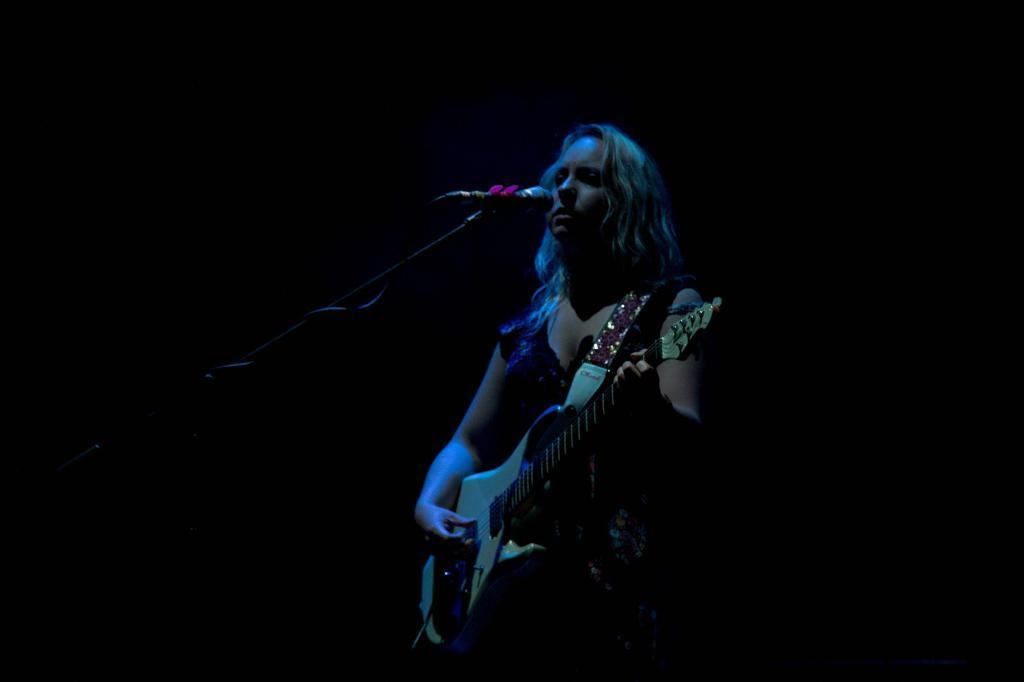What is the main subject of the image? There is a woman in the image. What is the woman doing in the image? The woman is standing on the floor and holding a guitar in her hand. What objects are related to the woman's activity in the image? There is a microphone and a microphone stand in the image. Can you see any planes flying in the image? There are no planes visible in the image. Are there any fairies present in the image? There are no fairies present in the image. 